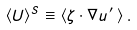<formula> <loc_0><loc_0><loc_500><loc_500>\langle { U } \rangle ^ { S } \equiv \langle \zeta \cdot \nabla { u } ^ { \, \prime } \, \rangle \, .</formula> 